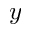Convert formula to latex. <formula><loc_0><loc_0><loc_500><loc_500>y</formula> 